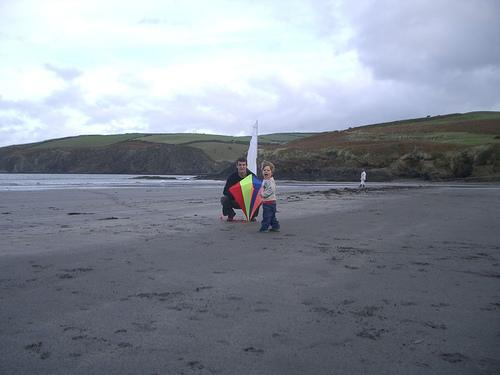What will this child hold while they play with this toy?

Choices:
A) tail
B) drone
C) string
D) control string 